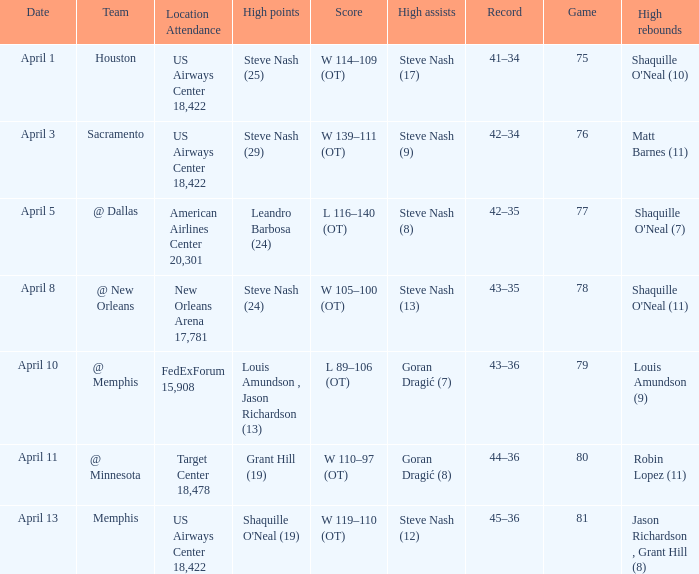Who did the most assists when Matt Barnes (11) got the most rebounds? Steve Nash (9). 